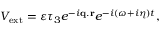Convert formula to latex. <formula><loc_0><loc_0><loc_500><loc_500>V _ { e x t } = \varepsilon \tau _ { 3 } e ^ { - i { q } . { r } } e ^ { - i ( \omega + i \eta ) t } ,</formula> 